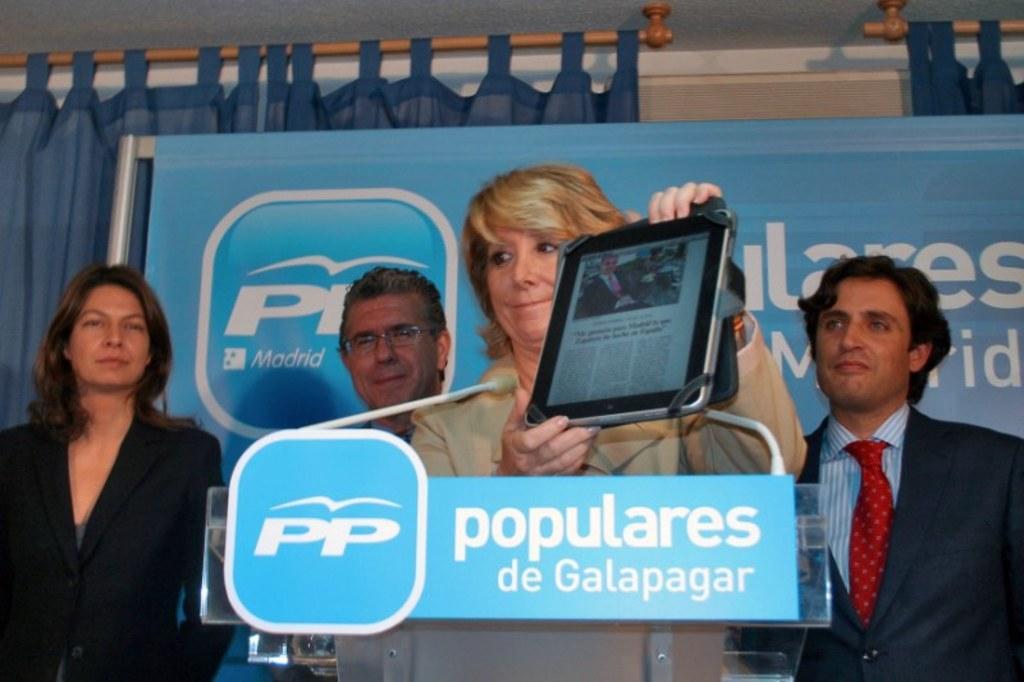Describe this image in one or two sentences. There is a text board at the bottom of this image. We can see a woman standing and holding an electronic device in the middle of this image. We can see other people in the background. There is a banner and curtains are present at the top of this image. 